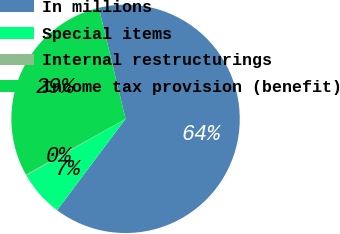Convert chart to OTSL. <chart><loc_0><loc_0><loc_500><loc_500><pie_chart><fcel>In millions<fcel>Special items<fcel>Internal restructurings<fcel>Income tax provision (benefit)<nl><fcel>63.99%<fcel>6.51%<fcel>0.13%<fcel>29.37%<nl></chart> 